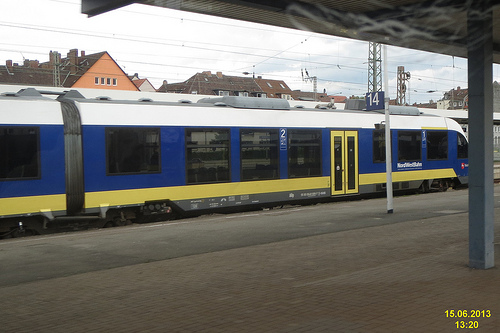Are there trains in front of the tower that is to the right of the house? Yes, there is a train prominently displayed in the foreground of the image with the tower to its left. 